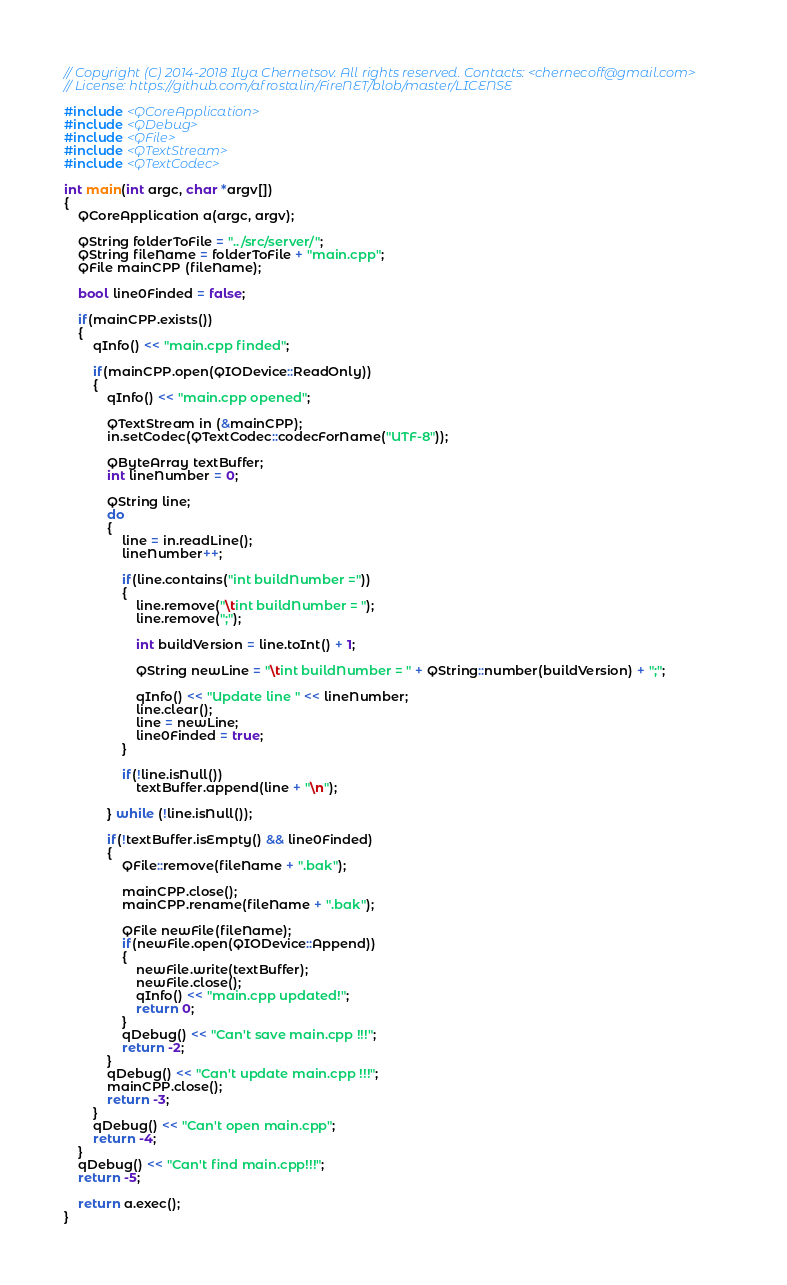<code> <loc_0><loc_0><loc_500><loc_500><_C++_>// Copyright (C) 2014-2018 Ilya Chernetsov. All rights reserved. Contacts: <chernecoff@gmail.com>
// License: https://github.com/afrostalin/FireNET/blob/master/LICENSE

#include <QCoreApplication>
#include <QDebug>
#include <QFile>
#include <QTextStream>
#include <QTextCodec>

int main(int argc, char *argv[])
{
    QCoreApplication a(argc, argv);

	QString folderToFile = "../src/server/";
	QString fileName = folderToFile + "main.cpp";
    QFile mainCPP (fileName);

    bool line0Finded = false;

    if(mainCPP.exists())
    {
        qInfo() << "main.cpp finded";

        if(mainCPP.open(QIODevice::ReadOnly))
        {
            qInfo() << "main.cpp opened";

            QTextStream in (&mainCPP);
            in.setCodec(QTextCodec::codecForName("UTF-8"));

            QByteArray textBuffer;
            int lineNumber = 0;

            QString line;
            do
            {
                line = in.readLine();
                lineNumber++;

                if(line.contains("int buildNumber ="))
                {
                    line.remove("\tint buildNumber = ");
                    line.remove(";");

                    int buildVersion = line.toInt() + 1;

                    QString newLine = "\tint buildNumber = " + QString::number(buildVersion) + ";";

                    qInfo() << "Update line " << lineNumber;
                    line.clear();
                    line = newLine;
                    line0Finded = true;
                }

                if(!line.isNull())
                    textBuffer.append(line + "\n");

            } while (!line.isNull());

            if(!textBuffer.isEmpty() && line0Finded)
            {
                QFile::remove(fileName + ".bak");

                mainCPP.close();
                mainCPP.rename(fileName + ".bak");

                QFile newFile(fileName);
                if(newFile.open(QIODevice::Append))
                {
                    newFile.write(textBuffer);
                    newFile.close();
                    qInfo() << "main.cpp updated!";
                    return 0;
                }
	            qDebug() << "Can't save main.cpp !!!";
	            return -2;
            }
	        qDebug() << "Can't update main.cpp !!!";
	        mainCPP.close();
	        return -3;
        }
	    qDebug() << "Can't open main.cpp";
	    return -4;
    }
	qDebug() << "Can't find main.cpp!!!";
	return -5;

	return a.exec();
}
</code> 